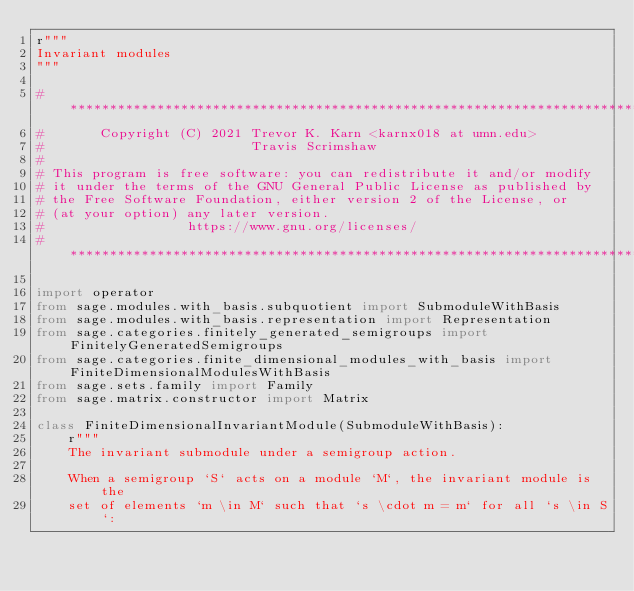<code> <loc_0><loc_0><loc_500><loc_500><_Python_>r"""
Invariant modules
"""

# ****************************************************************************
#       Copyright (C) 2021 Trevor K. Karn <karnx018 at umn.edu>
#                          Travis Scrimshaw
#
# This program is free software: you can redistribute it and/or modify
# it under the terms of the GNU General Public License as published by
# the Free Software Foundation, either version 2 of the License, or
# (at your option) any later version.
#                  https://www.gnu.org/licenses/
# ****************************************************************************

import operator
from sage.modules.with_basis.subquotient import SubmoduleWithBasis
from sage.modules.with_basis.representation import Representation
from sage.categories.finitely_generated_semigroups import FinitelyGeneratedSemigroups
from sage.categories.finite_dimensional_modules_with_basis import FiniteDimensionalModulesWithBasis
from sage.sets.family import Family
from sage.matrix.constructor import Matrix

class FiniteDimensionalInvariantModule(SubmoduleWithBasis):
    r"""
    The invariant submodule under a semigroup action.

    When a semigroup `S` acts on a module `M`, the invariant module is the
    set of elements `m \in M` such that `s \cdot m = m` for all `s \in S`:
</code> 